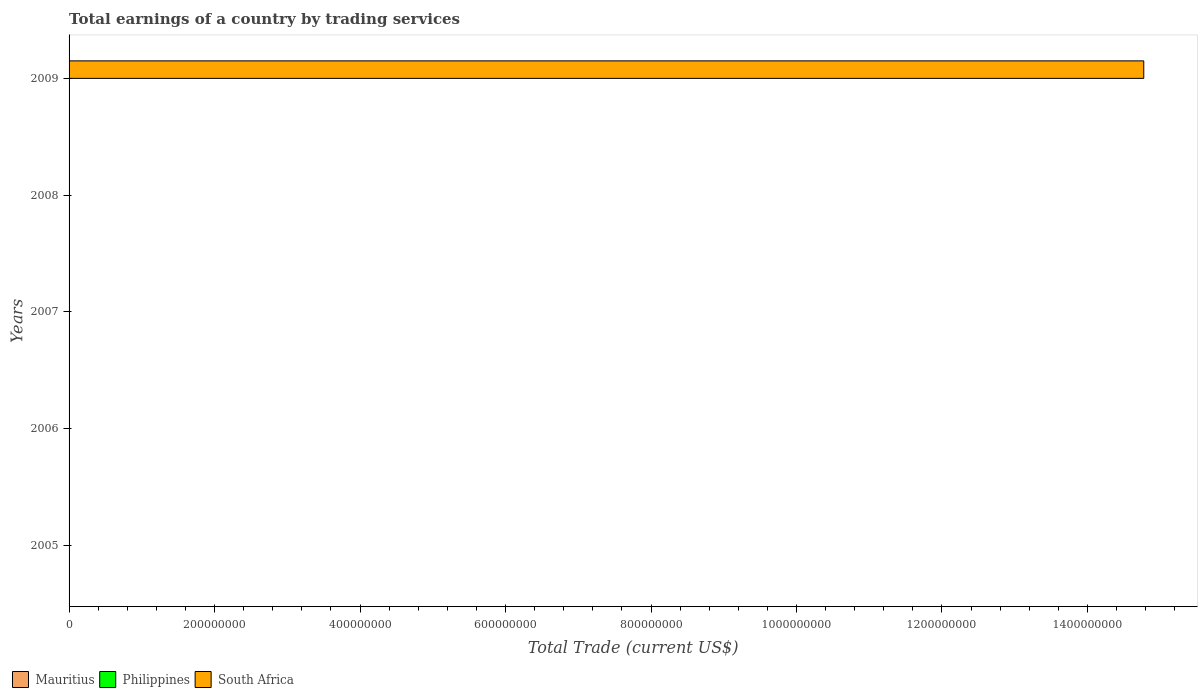How many different coloured bars are there?
Ensure brevity in your answer.  1. Are the number of bars per tick equal to the number of legend labels?
Provide a short and direct response. No. How many bars are there on the 4th tick from the top?
Make the answer very short. 0. What is the total earnings in South Africa in 2009?
Provide a short and direct response. 1.48e+09. Across all years, what is the maximum total earnings in South Africa?
Offer a very short reply. 1.48e+09. Across all years, what is the minimum total earnings in Mauritius?
Keep it short and to the point. 0. In which year was the total earnings in South Africa maximum?
Give a very brief answer. 2009. What is the average total earnings in South Africa per year?
Your response must be concise. 2.95e+08. In how many years, is the total earnings in Philippines greater than 1440000000 US$?
Your answer should be very brief. 0. What is the difference between the highest and the lowest total earnings in South Africa?
Offer a terse response. 1.48e+09. Is it the case that in every year, the sum of the total earnings in South Africa and total earnings in Philippines is greater than the total earnings in Mauritius?
Make the answer very short. No. How many bars are there?
Keep it short and to the point. 1. How many years are there in the graph?
Your response must be concise. 5. Are the values on the major ticks of X-axis written in scientific E-notation?
Your answer should be very brief. No. Does the graph contain grids?
Offer a very short reply. No. How many legend labels are there?
Offer a very short reply. 3. How are the legend labels stacked?
Your answer should be very brief. Horizontal. What is the title of the graph?
Your answer should be compact. Total earnings of a country by trading services. Does "Suriname" appear as one of the legend labels in the graph?
Your response must be concise. No. What is the label or title of the X-axis?
Keep it short and to the point. Total Trade (current US$). What is the label or title of the Y-axis?
Your response must be concise. Years. What is the Total Trade (current US$) in Mauritius in 2005?
Provide a succinct answer. 0. What is the Total Trade (current US$) of Philippines in 2005?
Offer a very short reply. 0. What is the Total Trade (current US$) of Mauritius in 2006?
Offer a terse response. 0. What is the Total Trade (current US$) in Philippines in 2007?
Your answer should be compact. 0. What is the Total Trade (current US$) of Philippines in 2008?
Offer a very short reply. 0. What is the Total Trade (current US$) in Philippines in 2009?
Give a very brief answer. 0. What is the Total Trade (current US$) in South Africa in 2009?
Your answer should be compact. 1.48e+09. Across all years, what is the maximum Total Trade (current US$) in South Africa?
Provide a succinct answer. 1.48e+09. What is the total Total Trade (current US$) in Mauritius in the graph?
Offer a terse response. 0. What is the total Total Trade (current US$) in Philippines in the graph?
Offer a terse response. 0. What is the total Total Trade (current US$) in South Africa in the graph?
Provide a succinct answer. 1.48e+09. What is the average Total Trade (current US$) in Mauritius per year?
Make the answer very short. 0. What is the average Total Trade (current US$) of Philippines per year?
Offer a terse response. 0. What is the average Total Trade (current US$) in South Africa per year?
Your response must be concise. 2.95e+08. What is the difference between the highest and the lowest Total Trade (current US$) in South Africa?
Provide a succinct answer. 1.48e+09. 